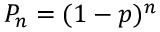<formula> <loc_0><loc_0><loc_500><loc_500>P _ { n } = ( 1 - p ) ^ { n }</formula> 